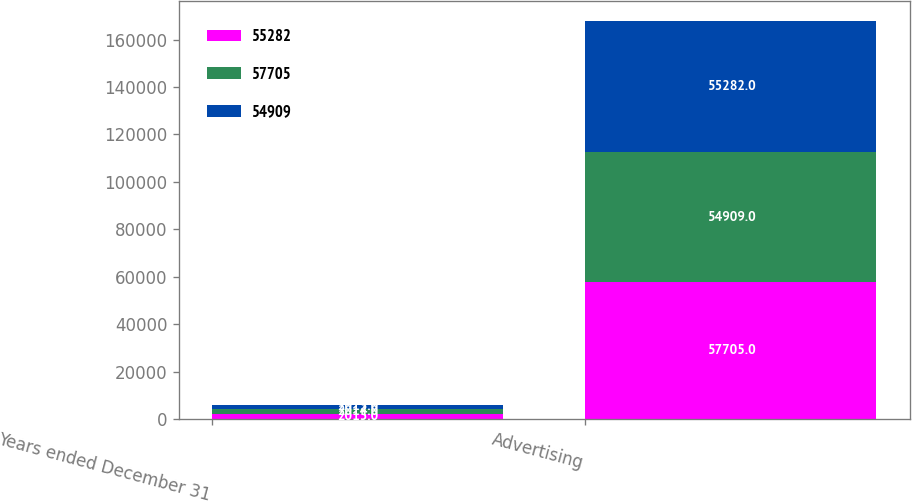<chart> <loc_0><loc_0><loc_500><loc_500><stacked_bar_chart><ecel><fcel>Years ended December 31<fcel>Advertising<nl><fcel>55282<fcel>2015<fcel>57705<nl><fcel>57705<fcel>2014<fcel>54909<nl><fcel>54909<fcel>2013<fcel>55282<nl></chart> 